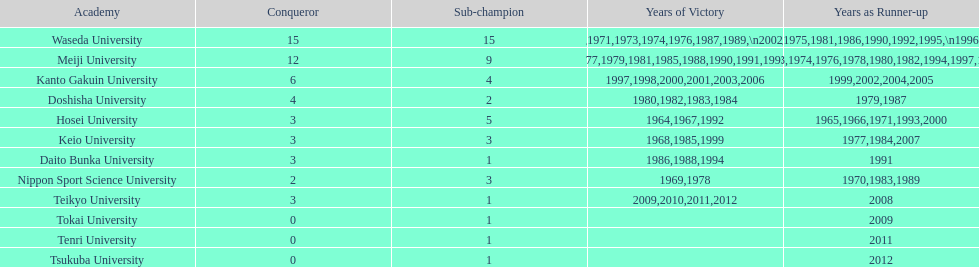After hosei's 1964 victory, who claimed the win in 1965? Waseda University. 